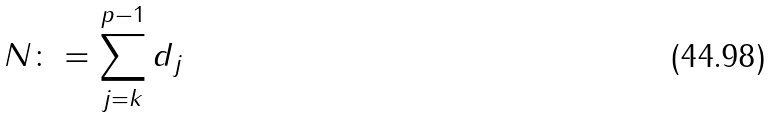Convert formula to latex. <formula><loc_0><loc_0><loc_500><loc_500>N \colon = \sum _ { j = k } ^ { p - 1 } d _ { j }</formula> 